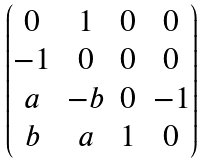Convert formula to latex. <formula><loc_0><loc_0><loc_500><loc_500>\begin{pmatrix} 0 & 1 & 0 & 0 \\ - 1 & 0 & 0 & 0 \\ a & - b & 0 & - 1 \\ b & a & 1 & 0 \end{pmatrix}</formula> 